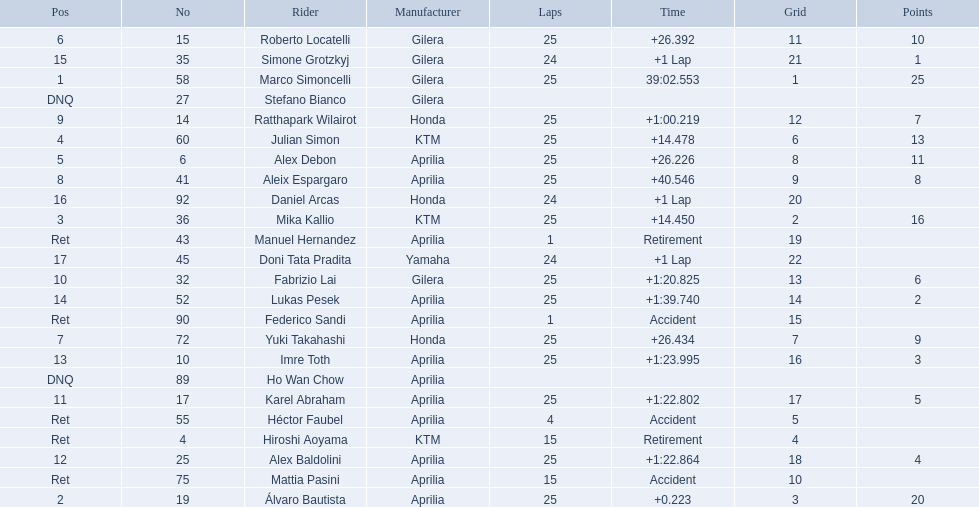What player number is marked #1 for the australian motorcycle grand prix? 58. Who is the rider that represents the #58 in the australian motorcycle grand prix? Marco Simoncelli. 